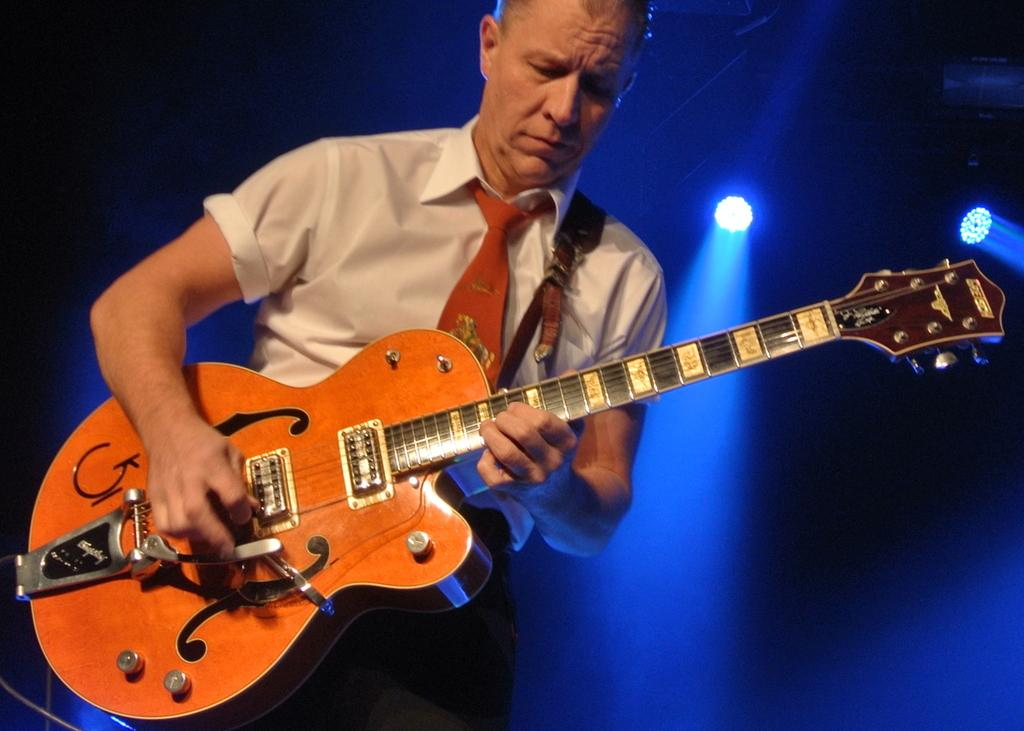What is the man in the image doing? The man is playing a guitar in the image. How is the man positioned in the image? The man is standing in the image. What is the man wearing in the image? The man is wearing a white shirt in the image. What can be seen in the background of the image? There are lights in the background of the image. What type of animal is the man riding in the image? There is no animal present in the image, and the man is not riding anything. 